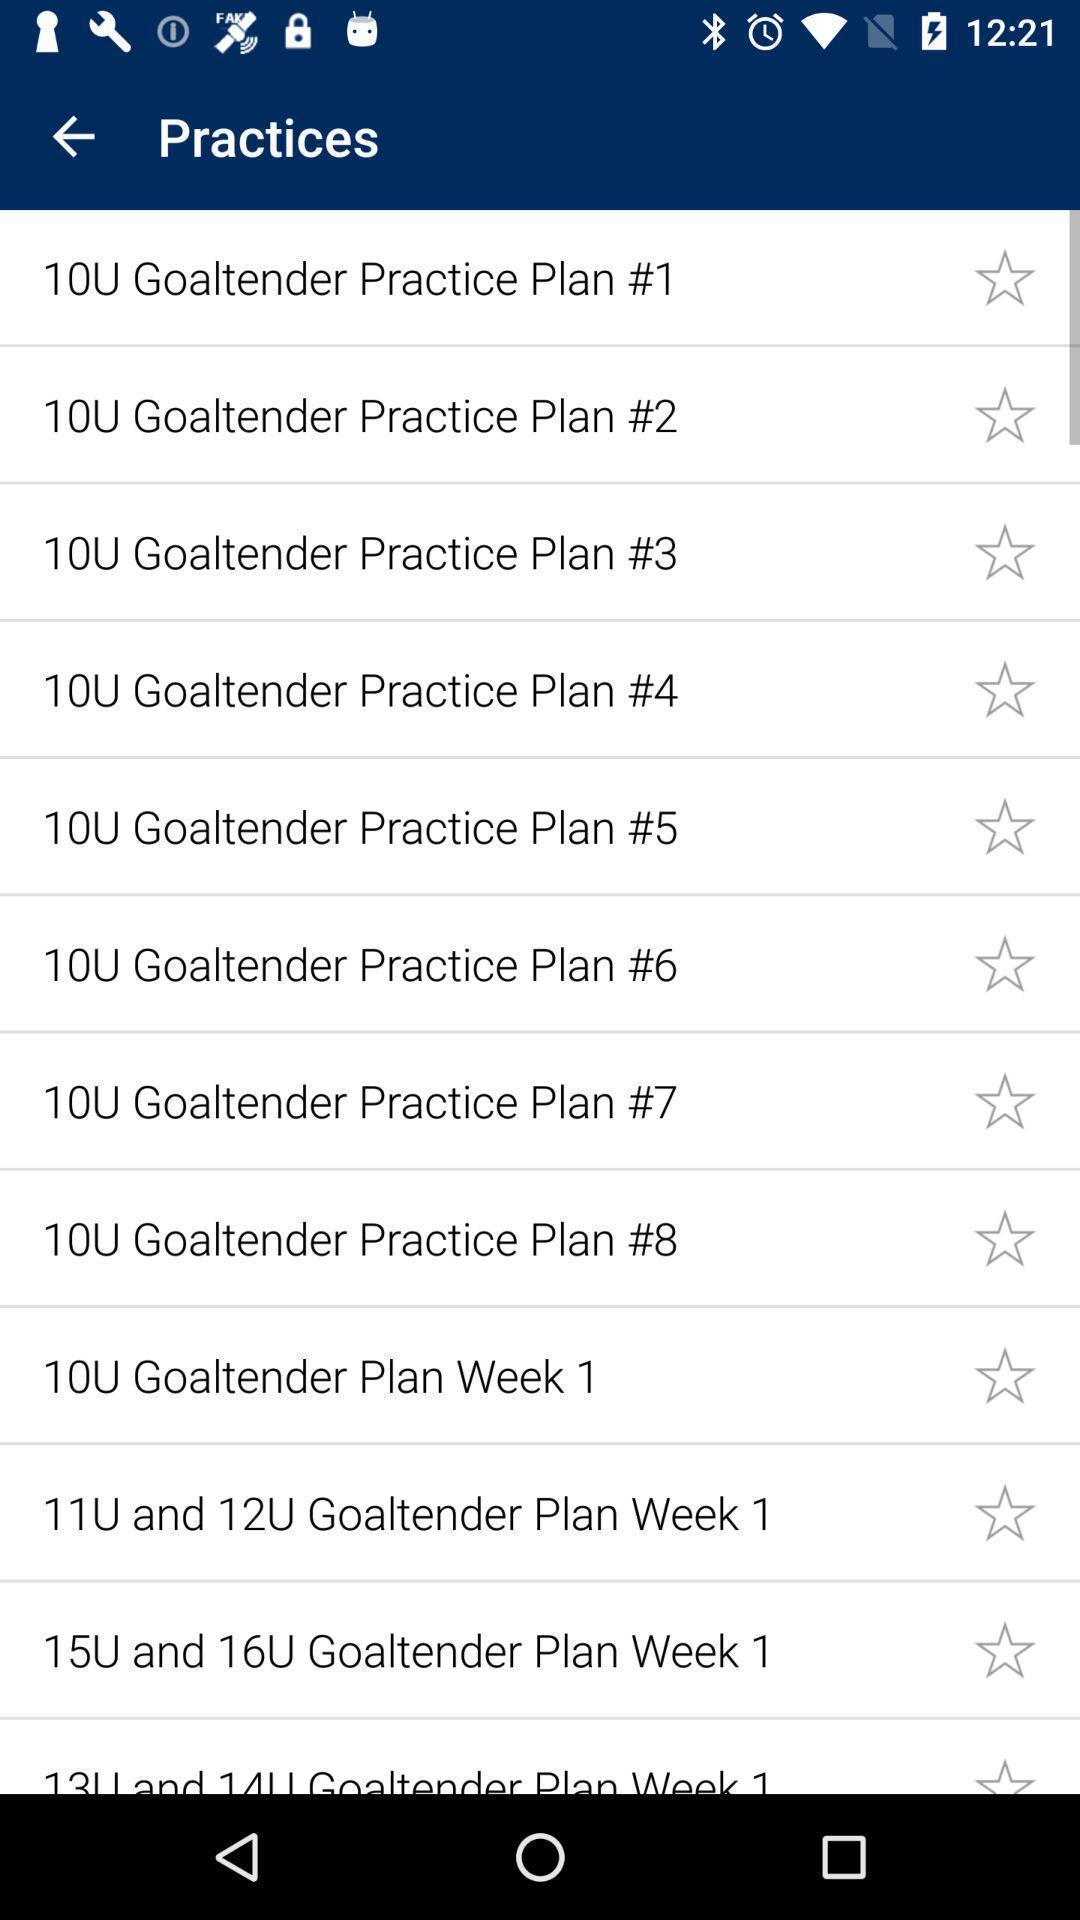Tell me about the visual elements in this screen capture. Page displaying list of practice options. 